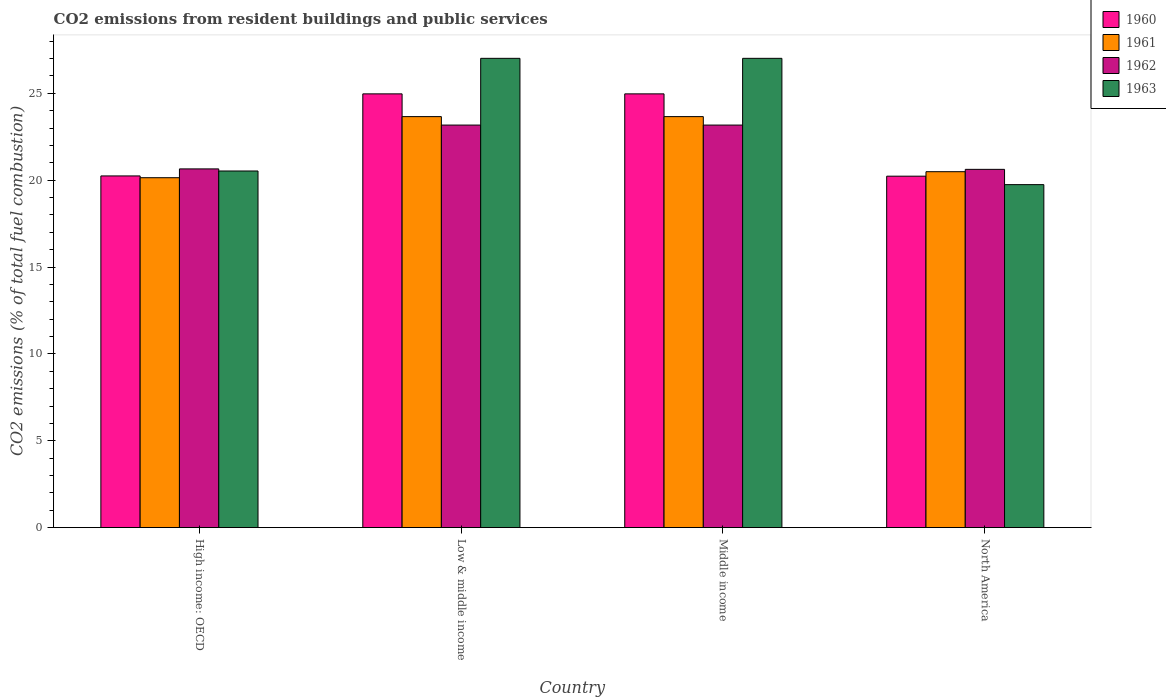How many different coloured bars are there?
Provide a succinct answer. 4. Are the number of bars per tick equal to the number of legend labels?
Ensure brevity in your answer.  Yes. Are the number of bars on each tick of the X-axis equal?
Your answer should be very brief. Yes. How many bars are there on the 1st tick from the right?
Ensure brevity in your answer.  4. What is the label of the 1st group of bars from the left?
Offer a terse response. High income: OECD. In how many cases, is the number of bars for a given country not equal to the number of legend labels?
Your answer should be very brief. 0. What is the total CO2 emitted in 1961 in Middle income?
Make the answer very short. 23.66. Across all countries, what is the maximum total CO2 emitted in 1962?
Your answer should be very brief. 23.17. Across all countries, what is the minimum total CO2 emitted in 1961?
Ensure brevity in your answer.  20.14. What is the total total CO2 emitted in 1962 in the graph?
Provide a short and direct response. 87.62. What is the difference between the total CO2 emitted in 1963 in Middle income and that in North America?
Keep it short and to the point. 7.27. What is the difference between the total CO2 emitted in 1962 in Low & middle income and the total CO2 emitted in 1961 in North America?
Give a very brief answer. 2.68. What is the average total CO2 emitted in 1962 per country?
Provide a short and direct response. 21.91. What is the difference between the total CO2 emitted of/in 1960 and total CO2 emitted of/in 1961 in High income: OECD?
Offer a terse response. 0.1. What is the ratio of the total CO2 emitted in 1963 in Middle income to that in North America?
Your answer should be compact. 1.37. Is the total CO2 emitted in 1962 in High income: OECD less than that in North America?
Make the answer very short. No. Is the difference between the total CO2 emitted in 1960 in High income: OECD and Low & middle income greater than the difference between the total CO2 emitted in 1961 in High income: OECD and Low & middle income?
Make the answer very short. No. What is the difference between the highest and the second highest total CO2 emitted in 1963?
Make the answer very short. 6.48. What is the difference between the highest and the lowest total CO2 emitted in 1960?
Ensure brevity in your answer.  4.74. Is the sum of the total CO2 emitted in 1960 in Low & middle income and Middle income greater than the maximum total CO2 emitted in 1963 across all countries?
Your answer should be very brief. Yes. Is it the case that in every country, the sum of the total CO2 emitted in 1960 and total CO2 emitted in 1963 is greater than the total CO2 emitted in 1962?
Give a very brief answer. Yes. What is the difference between two consecutive major ticks on the Y-axis?
Provide a succinct answer. 5. Does the graph contain any zero values?
Keep it short and to the point. No. Does the graph contain grids?
Offer a terse response. No. Where does the legend appear in the graph?
Offer a terse response. Top right. How many legend labels are there?
Provide a short and direct response. 4. How are the legend labels stacked?
Offer a terse response. Vertical. What is the title of the graph?
Your response must be concise. CO2 emissions from resident buildings and public services. What is the label or title of the Y-axis?
Your response must be concise. CO2 emissions (% of total fuel combustion). What is the CO2 emissions (% of total fuel combustion) of 1960 in High income: OECD?
Your answer should be very brief. 20.25. What is the CO2 emissions (% of total fuel combustion) in 1961 in High income: OECD?
Keep it short and to the point. 20.14. What is the CO2 emissions (% of total fuel combustion) of 1962 in High income: OECD?
Ensure brevity in your answer.  20.65. What is the CO2 emissions (% of total fuel combustion) of 1963 in High income: OECD?
Provide a short and direct response. 20.53. What is the CO2 emissions (% of total fuel combustion) of 1960 in Low & middle income?
Make the answer very short. 24.97. What is the CO2 emissions (% of total fuel combustion) in 1961 in Low & middle income?
Offer a terse response. 23.66. What is the CO2 emissions (% of total fuel combustion) in 1962 in Low & middle income?
Make the answer very short. 23.17. What is the CO2 emissions (% of total fuel combustion) in 1963 in Low & middle income?
Make the answer very short. 27.01. What is the CO2 emissions (% of total fuel combustion) of 1960 in Middle income?
Provide a short and direct response. 24.97. What is the CO2 emissions (% of total fuel combustion) of 1961 in Middle income?
Offer a terse response. 23.66. What is the CO2 emissions (% of total fuel combustion) in 1962 in Middle income?
Your answer should be compact. 23.17. What is the CO2 emissions (% of total fuel combustion) of 1963 in Middle income?
Provide a succinct answer. 27.01. What is the CO2 emissions (% of total fuel combustion) in 1960 in North America?
Your response must be concise. 20.23. What is the CO2 emissions (% of total fuel combustion) of 1961 in North America?
Your response must be concise. 20.49. What is the CO2 emissions (% of total fuel combustion) in 1962 in North America?
Offer a terse response. 20.62. What is the CO2 emissions (% of total fuel combustion) in 1963 in North America?
Your response must be concise. 19.74. Across all countries, what is the maximum CO2 emissions (% of total fuel combustion) in 1960?
Your answer should be compact. 24.97. Across all countries, what is the maximum CO2 emissions (% of total fuel combustion) in 1961?
Your answer should be compact. 23.66. Across all countries, what is the maximum CO2 emissions (% of total fuel combustion) of 1962?
Your answer should be very brief. 23.17. Across all countries, what is the maximum CO2 emissions (% of total fuel combustion) of 1963?
Your answer should be compact. 27.01. Across all countries, what is the minimum CO2 emissions (% of total fuel combustion) in 1960?
Ensure brevity in your answer.  20.23. Across all countries, what is the minimum CO2 emissions (% of total fuel combustion) in 1961?
Ensure brevity in your answer.  20.14. Across all countries, what is the minimum CO2 emissions (% of total fuel combustion) in 1962?
Provide a short and direct response. 20.62. Across all countries, what is the minimum CO2 emissions (% of total fuel combustion) of 1963?
Provide a succinct answer. 19.74. What is the total CO2 emissions (% of total fuel combustion) of 1960 in the graph?
Provide a short and direct response. 90.42. What is the total CO2 emissions (% of total fuel combustion) in 1961 in the graph?
Make the answer very short. 87.95. What is the total CO2 emissions (% of total fuel combustion) in 1962 in the graph?
Offer a terse response. 87.62. What is the total CO2 emissions (% of total fuel combustion) of 1963 in the graph?
Ensure brevity in your answer.  94.3. What is the difference between the CO2 emissions (% of total fuel combustion) of 1960 in High income: OECD and that in Low & middle income?
Ensure brevity in your answer.  -4.72. What is the difference between the CO2 emissions (% of total fuel combustion) in 1961 in High income: OECD and that in Low & middle income?
Ensure brevity in your answer.  -3.52. What is the difference between the CO2 emissions (% of total fuel combustion) of 1962 in High income: OECD and that in Low & middle income?
Your response must be concise. -2.52. What is the difference between the CO2 emissions (% of total fuel combustion) of 1963 in High income: OECD and that in Low & middle income?
Your answer should be very brief. -6.48. What is the difference between the CO2 emissions (% of total fuel combustion) of 1960 in High income: OECD and that in Middle income?
Give a very brief answer. -4.72. What is the difference between the CO2 emissions (% of total fuel combustion) of 1961 in High income: OECD and that in Middle income?
Ensure brevity in your answer.  -3.52. What is the difference between the CO2 emissions (% of total fuel combustion) of 1962 in High income: OECD and that in Middle income?
Give a very brief answer. -2.52. What is the difference between the CO2 emissions (% of total fuel combustion) in 1963 in High income: OECD and that in Middle income?
Offer a terse response. -6.48. What is the difference between the CO2 emissions (% of total fuel combustion) in 1960 in High income: OECD and that in North America?
Provide a succinct answer. 0.01. What is the difference between the CO2 emissions (% of total fuel combustion) of 1961 in High income: OECD and that in North America?
Give a very brief answer. -0.35. What is the difference between the CO2 emissions (% of total fuel combustion) of 1962 in High income: OECD and that in North America?
Your answer should be very brief. 0.03. What is the difference between the CO2 emissions (% of total fuel combustion) in 1963 in High income: OECD and that in North America?
Provide a succinct answer. 0.79. What is the difference between the CO2 emissions (% of total fuel combustion) of 1960 in Low & middle income and that in Middle income?
Your answer should be compact. 0. What is the difference between the CO2 emissions (% of total fuel combustion) in 1961 in Low & middle income and that in Middle income?
Make the answer very short. 0. What is the difference between the CO2 emissions (% of total fuel combustion) in 1963 in Low & middle income and that in Middle income?
Your answer should be compact. 0. What is the difference between the CO2 emissions (% of total fuel combustion) of 1960 in Low & middle income and that in North America?
Ensure brevity in your answer.  4.74. What is the difference between the CO2 emissions (% of total fuel combustion) in 1961 in Low & middle income and that in North America?
Your response must be concise. 3.17. What is the difference between the CO2 emissions (% of total fuel combustion) in 1962 in Low & middle income and that in North America?
Offer a very short reply. 2.55. What is the difference between the CO2 emissions (% of total fuel combustion) in 1963 in Low & middle income and that in North America?
Ensure brevity in your answer.  7.27. What is the difference between the CO2 emissions (% of total fuel combustion) of 1960 in Middle income and that in North America?
Give a very brief answer. 4.74. What is the difference between the CO2 emissions (% of total fuel combustion) of 1961 in Middle income and that in North America?
Your response must be concise. 3.17. What is the difference between the CO2 emissions (% of total fuel combustion) of 1962 in Middle income and that in North America?
Provide a short and direct response. 2.55. What is the difference between the CO2 emissions (% of total fuel combustion) of 1963 in Middle income and that in North America?
Ensure brevity in your answer.  7.27. What is the difference between the CO2 emissions (% of total fuel combustion) of 1960 in High income: OECD and the CO2 emissions (% of total fuel combustion) of 1961 in Low & middle income?
Your response must be concise. -3.41. What is the difference between the CO2 emissions (% of total fuel combustion) of 1960 in High income: OECD and the CO2 emissions (% of total fuel combustion) of 1962 in Low & middle income?
Your response must be concise. -2.93. What is the difference between the CO2 emissions (% of total fuel combustion) in 1960 in High income: OECD and the CO2 emissions (% of total fuel combustion) in 1963 in Low & middle income?
Make the answer very short. -6.77. What is the difference between the CO2 emissions (% of total fuel combustion) of 1961 in High income: OECD and the CO2 emissions (% of total fuel combustion) of 1962 in Low & middle income?
Provide a short and direct response. -3.03. What is the difference between the CO2 emissions (% of total fuel combustion) of 1961 in High income: OECD and the CO2 emissions (% of total fuel combustion) of 1963 in Low & middle income?
Offer a very short reply. -6.87. What is the difference between the CO2 emissions (% of total fuel combustion) in 1962 in High income: OECD and the CO2 emissions (% of total fuel combustion) in 1963 in Low & middle income?
Offer a terse response. -6.36. What is the difference between the CO2 emissions (% of total fuel combustion) of 1960 in High income: OECD and the CO2 emissions (% of total fuel combustion) of 1961 in Middle income?
Provide a short and direct response. -3.41. What is the difference between the CO2 emissions (% of total fuel combustion) of 1960 in High income: OECD and the CO2 emissions (% of total fuel combustion) of 1962 in Middle income?
Your answer should be compact. -2.93. What is the difference between the CO2 emissions (% of total fuel combustion) in 1960 in High income: OECD and the CO2 emissions (% of total fuel combustion) in 1963 in Middle income?
Your response must be concise. -6.77. What is the difference between the CO2 emissions (% of total fuel combustion) of 1961 in High income: OECD and the CO2 emissions (% of total fuel combustion) of 1962 in Middle income?
Your response must be concise. -3.03. What is the difference between the CO2 emissions (% of total fuel combustion) of 1961 in High income: OECD and the CO2 emissions (% of total fuel combustion) of 1963 in Middle income?
Offer a very short reply. -6.87. What is the difference between the CO2 emissions (% of total fuel combustion) of 1962 in High income: OECD and the CO2 emissions (% of total fuel combustion) of 1963 in Middle income?
Your response must be concise. -6.36. What is the difference between the CO2 emissions (% of total fuel combustion) in 1960 in High income: OECD and the CO2 emissions (% of total fuel combustion) in 1961 in North America?
Make the answer very short. -0.24. What is the difference between the CO2 emissions (% of total fuel combustion) of 1960 in High income: OECD and the CO2 emissions (% of total fuel combustion) of 1962 in North America?
Keep it short and to the point. -0.38. What is the difference between the CO2 emissions (% of total fuel combustion) in 1960 in High income: OECD and the CO2 emissions (% of total fuel combustion) in 1963 in North America?
Offer a terse response. 0.5. What is the difference between the CO2 emissions (% of total fuel combustion) in 1961 in High income: OECD and the CO2 emissions (% of total fuel combustion) in 1962 in North America?
Offer a terse response. -0.48. What is the difference between the CO2 emissions (% of total fuel combustion) in 1961 in High income: OECD and the CO2 emissions (% of total fuel combustion) in 1963 in North America?
Provide a succinct answer. 0.4. What is the difference between the CO2 emissions (% of total fuel combustion) of 1962 in High income: OECD and the CO2 emissions (% of total fuel combustion) of 1963 in North America?
Your response must be concise. 0.91. What is the difference between the CO2 emissions (% of total fuel combustion) in 1960 in Low & middle income and the CO2 emissions (% of total fuel combustion) in 1961 in Middle income?
Offer a terse response. 1.31. What is the difference between the CO2 emissions (% of total fuel combustion) in 1960 in Low & middle income and the CO2 emissions (% of total fuel combustion) in 1962 in Middle income?
Ensure brevity in your answer.  1.8. What is the difference between the CO2 emissions (% of total fuel combustion) of 1960 in Low & middle income and the CO2 emissions (% of total fuel combustion) of 1963 in Middle income?
Your answer should be very brief. -2.05. What is the difference between the CO2 emissions (% of total fuel combustion) in 1961 in Low & middle income and the CO2 emissions (% of total fuel combustion) in 1962 in Middle income?
Your answer should be very brief. 0.49. What is the difference between the CO2 emissions (% of total fuel combustion) in 1961 in Low & middle income and the CO2 emissions (% of total fuel combustion) in 1963 in Middle income?
Make the answer very short. -3.35. What is the difference between the CO2 emissions (% of total fuel combustion) of 1962 in Low & middle income and the CO2 emissions (% of total fuel combustion) of 1963 in Middle income?
Make the answer very short. -3.84. What is the difference between the CO2 emissions (% of total fuel combustion) of 1960 in Low & middle income and the CO2 emissions (% of total fuel combustion) of 1961 in North America?
Your response must be concise. 4.48. What is the difference between the CO2 emissions (% of total fuel combustion) of 1960 in Low & middle income and the CO2 emissions (% of total fuel combustion) of 1962 in North America?
Provide a short and direct response. 4.35. What is the difference between the CO2 emissions (% of total fuel combustion) of 1960 in Low & middle income and the CO2 emissions (% of total fuel combustion) of 1963 in North America?
Your answer should be compact. 5.22. What is the difference between the CO2 emissions (% of total fuel combustion) in 1961 in Low & middle income and the CO2 emissions (% of total fuel combustion) in 1962 in North America?
Provide a succinct answer. 3.04. What is the difference between the CO2 emissions (% of total fuel combustion) in 1961 in Low & middle income and the CO2 emissions (% of total fuel combustion) in 1963 in North America?
Offer a very short reply. 3.92. What is the difference between the CO2 emissions (% of total fuel combustion) of 1962 in Low & middle income and the CO2 emissions (% of total fuel combustion) of 1963 in North America?
Your response must be concise. 3.43. What is the difference between the CO2 emissions (% of total fuel combustion) in 1960 in Middle income and the CO2 emissions (% of total fuel combustion) in 1961 in North America?
Your answer should be very brief. 4.48. What is the difference between the CO2 emissions (% of total fuel combustion) in 1960 in Middle income and the CO2 emissions (% of total fuel combustion) in 1962 in North America?
Offer a very short reply. 4.35. What is the difference between the CO2 emissions (% of total fuel combustion) of 1960 in Middle income and the CO2 emissions (% of total fuel combustion) of 1963 in North America?
Offer a terse response. 5.22. What is the difference between the CO2 emissions (% of total fuel combustion) of 1961 in Middle income and the CO2 emissions (% of total fuel combustion) of 1962 in North America?
Provide a short and direct response. 3.04. What is the difference between the CO2 emissions (% of total fuel combustion) of 1961 in Middle income and the CO2 emissions (% of total fuel combustion) of 1963 in North America?
Your response must be concise. 3.92. What is the difference between the CO2 emissions (% of total fuel combustion) in 1962 in Middle income and the CO2 emissions (% of total fuel combustion) in 1963 in North America?
Provide a short and direct response. 3.43. What is the average CO2 emissions (% of total fuel combustion) of 1960 per country?
Ensure brevity in your answer.  22.6. What is the average CO2 emissions (% of total fuel combustion) of 1961 per country?
Your answer should be compact. 21.99. What is the average CO2 emissions (% of total fuel combustion) in 1962 per country?
Make the answer very short. 21.91. What is the average CO2 emissions (% of total fuel combustion) of 1963 per country?
Your response must be concise. 23.58. What is the difference between the CO2 emissions (% of total fuel combustion) of 1960 and CO2 emissions (% of total fuel combustion) of 1961 in High income: OECD?
Give a very brief answer. 0.1. What is the difference between the CO2 emissions (% of total fuel combustion) in 1960 and CO2 emissions (% of total fuel combustion) in 1962 in High income: OECD?
Offer a terse response. -0.4. What is the difference between the CO2 emissions (% of total fuel combustion) in 1960 and CO2 emissions (% of total fuel combustion) in 1963 in High income: OECD?
Give a very brief answer. -0.28. What is the difference between the CO2 emissions (% of total fuel combustion) of 1961 and CO2 emissions (% of total fuel combustion) of 1962 in High income: OECD?
Make the answer very short. -0.51. What is the difference between the CO2 emissions (% of total fuel combustion) in 1961 and CO2 emissions (% of total fuel combustion) in 1963 in High income: OECD?
Your answer should be very brief. -0.39. What is the difference between the CO2 emissions (% of total fuel combustion) in 1962 and CO2 emissions (% of total fuel combustion) in 1963 in High income: OECD?
Your response must be concise. 0.12. What is the difference between the CO2 emissions (% of total fuel combustion) in 1960 and CO2 emissions (% of total fuel combustion) in 1961 in Low & middle income?
Ensure brevity in your answer.  1.31. What is the difference between the CO2 emissions (% of total fuel combustion) of 1960 and CO2 emissions (% of total fuel combustion) of 1962 in Low & middle income?
Offer a terse response. 1.8. What is the difference between the CO2 emissions (% of total fuel combustion) in 1960 and CO2 emissions (% of total fuel combustion) in 1963 in Low & middle income?
Make the answer very short. -2.05. What is the difference between the CO2 emissions (% of total fuel combustion) in 1961 and CO2 emissions (% of total fuel combustion) in 1962 in Low & middle income?
Provide a succinct answer. 0.49. What is the difference between the CO2 emissions (% of total fuel combustion) in 1961 and CO2 emissions (% of total fuel combustion) in 1963 in Low & middle income?
Offer a terse response. -3.35. What is the difference between the CO2 emissions (% of total fuel combustion) of 1962 and CO2 emissions (% of total fuel combustion) of 1963 in Low & middle income?
Your answer should be very brief. -3.84. What is the difference between the CO2 emissions (% of total fuel combustion) of 1960 and CO2 emissions (% of total fuel combustion) of 1961 in Middle income?
Offer a very short reply. 1.31. What is the difference between the CO2 emissions (% of total fuel combustion) of 1960 and CO2 emissions (% of total fuel combustion) of 1962 in Middle income?
Give a very brief answer. 1.8. What is the difference between the CO2 emissions (% of total fuel combustion) in 1960 and CO2 emissions (% of total fuel combustion) in 1963 in Middle income?
Make the answer very short. -2.05. What is the difference between the CO2 emissions (% of total fuel combustion) of 1961 and CO2 emissions (% of total fuel combustion) of 1962 in Middle income?
Make the answer very short. 0.49. What is the difference between the CO2 emissions (% of total fuel combustion) of 1961 and CO2 emissions (% of total fuel combustion) of 1963 in Middle income?
Your answer should be compact. -3.35. What is the difference between the CO2 emissions (% of total fuel combustion) in 1962 and CO2 emissions (% of total fuel combustion) in 1963 in Middle income?
Your answer should be very brief. -3.84. What is the difference between the CO2 emissions (% of total fuel combustion) of 1960 and CO2 emissions (% of total fuel combustion) of 1961 in North America?
Your answer should be compact. -0.26. What is the difference between the CO2 emissions (% of total fuel combustion) in 1960 and CO2 emissions (% of total fuel combustion) in 1962 in North America?
Your response must be concise. -0.39. What is the difference between the CO2 emissions (% of total fuel combustion) in 1960 and CO2 emissions (% of total fuel combustion) in 1963 in North America?
Give a very brief answer. 0.49. What is the difference between the CO2 emissions (% of total fuel combustion) in 1961 and CO2 emissions (% of total fuel combustion) in 1962 in North America?
Your answer should be very brief. -0.14. What is the difference between the CO2 emissions (% of total fuel combustion) in 1961 and CO2 emissions (% of total fuel combustion) in 1963 in North America?
Your answer should be very brief. 0.74. What is the difference between the CO2 emissions (% of total fuel combustion) of 1962 and CO2 emissions (% of total fuel combustion) of 1963 in North America?
Your response must be concise. 0.88. What is the ratio of the CO2 emissions (% of total fuel combustion) in 1960 in High income: OECD to that in Low & middle income?
Give a very brief answer. 0.81. What is the ratio of the CO2 emissions (% of total fuel combustion) of 1961 in High income: OECD to that in Low & middle income?
Offer a terse response. 0.85. What is the ratio of the CO2 emissions (% of total fuel combustion) of 1962 in High income: OECD to that in Low & middle income?
Your answer should be compact. 0.89. What is the ratio of the CO2 emissions (% of total fuel combustion) of 1963 in High income: OECD to that in Low & middle income?
Provide a short and direct response. 0.76. What is the ratio of the CO2 emissions (% of total fuel combustion) in 1960 in High income: OECD to that in Middle income?
Offer a very short reply. 0.81. What is the ratio of the CO2 emissions (% of total fuel combustion) of 1961 in High income: OECD to that in Middle income?
Offer a very short reply. 0.85. What is the ratio of the CO2 emissions (% of total fuel combustion) in 1962 in High income: OECD to that in Middle income?
Offer a very short reply. 0.89. What is the ratio of the CO2 emissions (% of total fuel combustion) in 1963 in High income: OECD to that in Middle income?
Your answer should be compact. 0.76. What is the ratio of the CO2 emissions (% of total fuel combustion) in 1960 in High income: OECD to that in North America?
Offer a terse response. 1. What is the ratio of the CO2 emissions (% of total fuel combustion) of 1961 in High income: OECD to that in North America?
Your response must be concise. 0.98. What is the ratio of the CO2 emissions (% of total fuel combustion) of 1963 in High income: OECD to that in North America?
Your answer should be very brief. 1.04. What is the ratio of the CO2 emissions (% of total fuel combustion) of 1960 in Low & middle income to that in Middle income?
Provide a succinct answer. 1. What is the ratio of the CO2 emissions (% of total fuel combustion) in 1962 in Low & middle income to that in Middle income?
Offer a very short reply. 1. What is the ratio of the CO2 emissions (% of total fuel combustion) in 1960 in Low & middle income to that in North America?
Make the answer very short. 1.23. What is the ratio of the CO2 emissions (% of total fuel combustion) of 1961 in Low & middle income to that in North America?
Offer a very short reply. 1.15. What is the ratio of the CO2 emissions (% of total fuel combustion) in 1962 in Low & middle income to that in North America?
Ensure brevity in your answer.  1.12. What is the ratio of the CO2 emissions (% of total fuel combustion) of 1963 in Low & middle income to that in North America?
Your response must be concise. 1.37. What is the ratio of the CO2 emissions (% of total fuel combustion) of 1960 in Middle income to that in North America?
Your answer should be very brief. 1.23. What is the ratio of the CO2 emissions (% of total fuel combustion) in 1961 in Middle income to that in North America?
Your answer should be very brief. 1.15. What is the ratio of the CO2 emissions (% of total fuel combustion) in 1962 in Middle income to that in North America?
Ensure brevity in your answer.  1.12. What is the ratio of the CO2 emissions (% of total fuel combustion) of 1963 in Middle income to that in North America?
Make the answer very short. 1.37. What is the difference between the highest and the second highest CO2 emissions (% of total fuel combustion) of 1960?
Make the answer very short. 0. What is the difference between the highest and the second highest CO2 emissions (% of total fuel combustion) in 1962?
Your answer should be compact. 0. What is the difference between the highest and the second highest CO2 emissions (% of total fuel combustion) in 1963?
Keep it short and to the point. 0. What is the difference between the highest and the lowest CO2 emissions (% of total fuel combustion) in 1960?
Offer a very short reply. 4.74. What is the difference between the highest and the lowest CO2 emissions (% of total fuel combustion) in 1961?
Give a very brief answer. 3.52. What is the difference between the highest and the lowest CO2 emissions (% of total fuel combustion) of 1962?
Your answer should be very brief. 2.55. What is the difference between the highest and the lowest CO2 emissions (% of total fuel combustion) in 1963?
Your response must be concise. 7.27. 